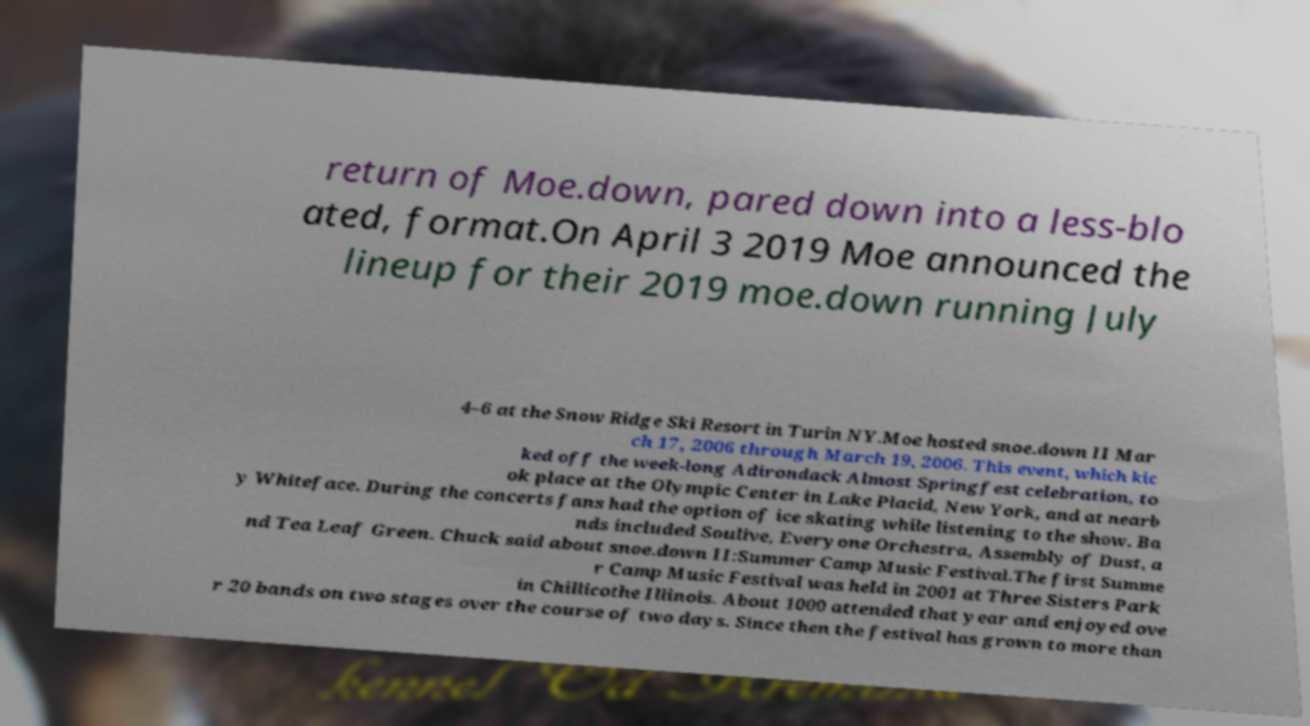Please identify and transcribe the text found in this image. return of Moe.down, pared down into a less-blo ated, format.On April 3 2019 Moe announced the lineup for their 2019 moe.down running July 4–6 at the Snow Ridge Ski Resort in Turin NY.Moe hosted snoe.down II Mar ch 17, 2006 through March 19, 2006. This event, which kic ked off the week-long Adirondack Almost Springfest celebration, to ok place at the Olympic Center in Lake Placid, New York, and at nearb y Whiteface. During the concerts fans had the option of ice skating while listening to the show. Ba nds included Soulive, Everyone Orchestra, Assembly of Dust, a nd Tea Leaf Green. Chuck said about snoe.down II:Summer Camp Music Festival.The first Summe r Camp Music Festival was held in 2001 at Three Sisters Park in Chillicothe Illinois. About 1000 attended that year and enjoyed ove r 20 bands on two stages over the course of two days. Since then the festival has grown to more than 